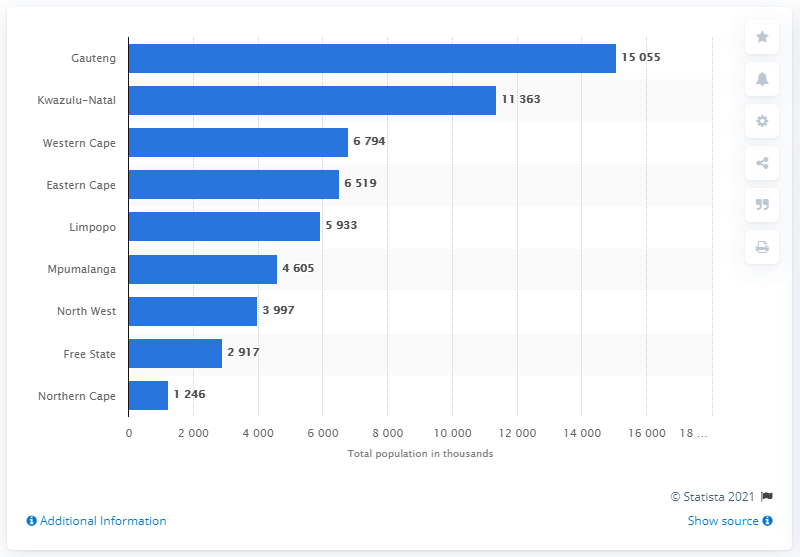Identify some key points in this picture. Gauteng is the smallest province of South Africa. 